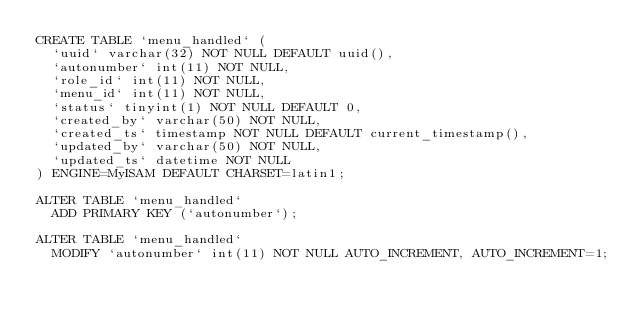<code> <loc_0><loc_0><loc_500><loc_500><_SQL_>CREATE TABLE `menu_handled` (
  `uuid` varchar(32) NOT NULL DEFAULT uuid(),
  `autonumber` int(11) NOT NULL,
  `role_id` int(11) NOT NULL,
  `menu_id` int(11) NOT NULL,
  `status` tinyint(1) NOT NULL DEFAULT 0,
  `created_by` varchar(50) NOT NULL,
  `created_ts` timestamp NOT NULL DEFAULT current_timestamp(),
  `updated_by` varchar(50) NOT NULL,
  `updated_ts` datetime NOT NULL
) ENGINE=MyISAM DEFAULT CHARSET=latin1;

ALTER TABLE `menu_handled` 
  ADD PRIMARY KEY (`autonumber`);

ALTER TABLE `menu_handled`
  MODIFY `autonumber` int(11) NOT NULL AUTO_INCREMENT, AUTO_INCREMENT=1;</code> 